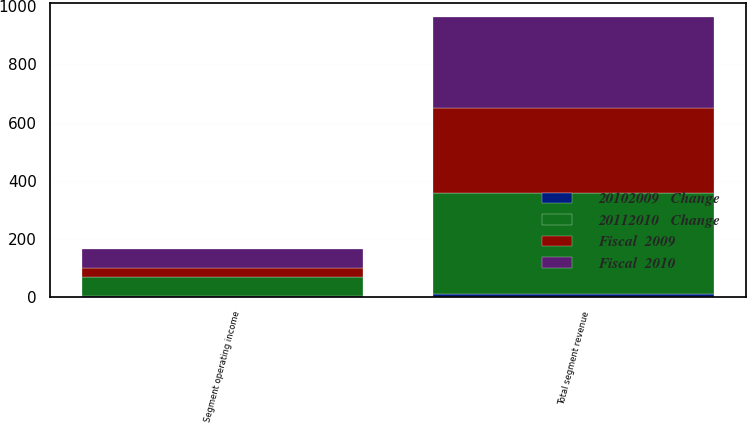<chart> <loc_0><loc_0><loc_500><loc_500><stacked_bar_chart><ecel><fcel>Total segment revenue<fcel>Segment operating income<nl><fcel>20112010   Change<fcel>348<fcel>64<nl><fcel>Fiscal  2010<fcel>313<fcel>67<nl><fcel>Fiscal  2009<fcel>291<fcel>31<nl><fcel>20102009   Change<fcel>11<fcel>3<nl></chart> 